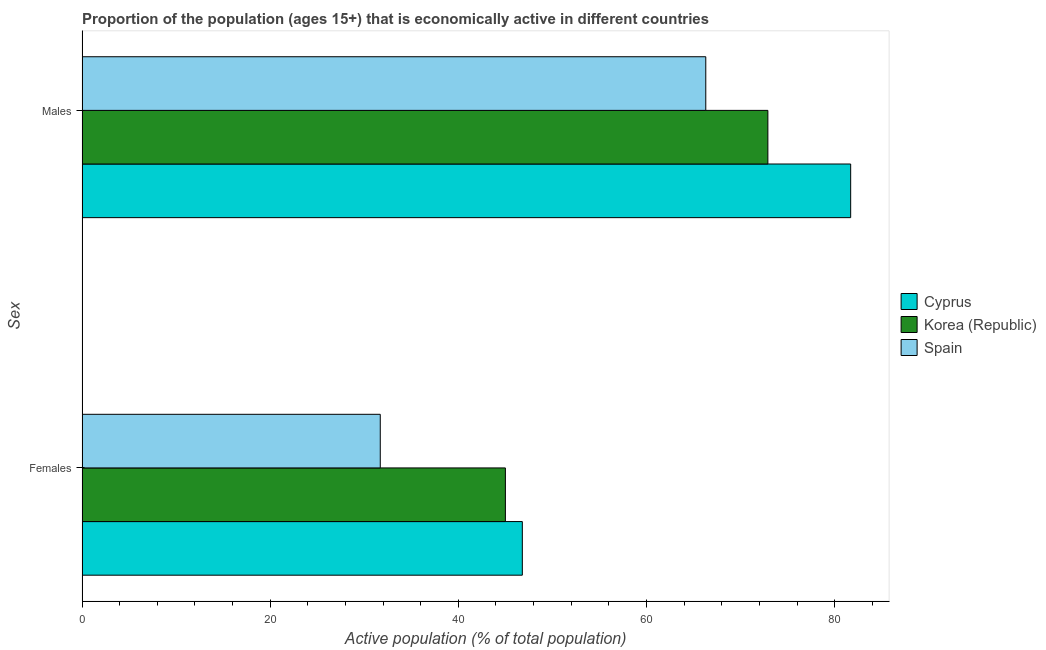How many different coloured bars are there?
Provide a short and direct response. 3. How many groups of bars are there?
Give a very brief answer. 2. Are the number of bars per tick equal to the number of legend labels?
Your response must be concise. Yes. How many bars are there on the 2nd tick from the top?
Provide a short and direct response. 3. What is the label of the 2nd group of bars from the top?
Provide a short and direct response. Females. What is the percentage of economically active female population in Spain?
Offer a terse response. 31.7. Across all countries, what is the maximum percentage of economically active male population?
Make the answer very short. 81.7. Across all countries, what is the minimum percentage of economically active female population?
Make the answer very short. 31.7. In which country was the percentage of economically active male population maximum?
Your answer should be compact. Cyprus. In which country was the percentage of economically active male population minimum?
Offer a terse response. Spain. What is the total percentage of economically active female population in the graph?
Ensure brevity in your answer.  123.5. What is the difference between the percentage of economically active female population in Korea (Republic) and that in Spain?
Your answer should be compact. 13.3. What is the difference between the percentage of economically active female population in Cyprus and the percentage of economically active male population in Korea (Republic)?
Ensure brevity in your answer.  -26.1. What is the average percentage of economically active female population per country?
Your response must be concise. 41.17. What is the difference between the percentage of economically active female population and percentage of economically active male population in Cyprus?
Provide a short and direct response. -34.9. What is the ratio of the percentage of economically active female population in Cyprus to that in Spain?
Ensure brevity in your answer.  1.48. In how many countries, is the percentage of economically active male population greater than the average percentage of economically active male population taken over all countries?
Provide a short and direct response. 1. What does the 1st bar from the bottom in Females represents?
Give a very brief answer. Cyprus. What is the difference between two consecutive major ticks on the X-axis?
Give a very brief answer. 20. Are the values on the major ticks of X-axis written in scientific E-notation?
Provide a succinct answer. No. Does the graph contain grids?
Your answer should be very brief. No. How are the legend labels stacked?
Give a very brief answer. Vertical. What is the title of the graph?
Make the answer very short. Proportion of the population (ages 15+) that is economically active in different countries. Does "Macedonia" appear as one of the legend labels in the graph?
Your response must be concise. No. What is the label or title of the X-axis?
Offer a terse response. Active population (% of total population). What is the label or title of the Y-axis?
Offer a very short reply. Sex. What is the Active population (% of total population) of Cyprus in Females?
Ensure brevity in your answer.  46.8. What is the Active population (% of total population) of Spain in Females?
Keep it short and to the point. 31.7. What is the Active population (% of total population) in Cyprus in Males?
Offer a terse response. 81.7. What is the Active population (% of total population) of Korea (Republic) in Males?
Your answer should be very brief. 72.9. What is the Active population (% of total population) of Spain in Males?
Your answer should be very brief. 66.3. Across all Sex, what is the maximum Active population (% of total population) in Cyprus?
Offer a terse response. 81.7. Across all Sex, what is the maximum Active population (% of total population) of Korea (Republic)?
Ensure brevity in your answer.  72.9. Across all Sex, what is the maximum Active population (% of total population) in Spain?
Your answer should be very brief. 66.3. Across all Sex, what is the minimum Active population (% of total population) in Cyprus?
Offer a very short reply. 46.8. Across all Sex, what is the minimum Active population (% of total population) of Korea (Republic)?
Provide a succinct answer. 45. Across all Sex, what is the minimum Active population (% of total population) in Spain?
Make the answer very short. 31.7. What is the total Active population (% of total population) in Cyprus in the graph?
Your response must be concise. 128.5. What is the total Active population (% of total population) of Korea (Republic) in the graph?
Your answer should be compact. 117.9. What is the difference between the Active population (% of total population) in Cyprus in Females and that in Males?
Provide a succinct answer. -34.9. What is the difference between the Active population (% of total population) of Korea (Republic) in Females and that in Males?
Your answer should be very brief. -27.9. What is the difference between the Active population (% of total population) in Spain in Females and that in Males?
Ensure brevity in your answer.  -34.6. What is the difference between the Active population (% of total population) in Cyprus in Females and the Active population (% of total population) in Korea (Republic) in Males?
Ensure brevity in your answer.  -26.1. What is the difference between the Active population (% of total population) of Cyprus in Females and the Active population (% of total population) of Spain in Males?
Your answer should be very brief. -19.5. What is the difference between the Active population (% of total population) of Korea (Republic) in Females and the Active population (% of total population) of Spain in Males?
Keep it short and to the point. -21.3. What is the average Active population (% of total population) of Cyprus per Sex?
Provide a short and direct response. 64.25. What is the average Active population (% of total population) of Korea (Republic) per Sex?
Your response must be concise. 58.95. What is the average Active population (% of total population) of Spain per Sex?
Provide a succinct answer. 49. What is the difference between the Active population (% of total population) of Cyprus and Active population (% of total population) of Korea (Republic) in Females?
Provide a succinct answer. 1.8. What is the difference between the Active population (% of total population) of Korea (Republic) and Active population (% of total population) of Spain in Males?
Give a very brief answer. 6.6. What is the ratio of the Active population (% of total population) in Cyprus in Females to that in Males?
Your answer should be very brief. 0.57. What is the ratio of the Active population (% of total population) of Korea (Republic) in Females to that in Males?
Ensure brevity in your answer.  0.62. What is the ratio of the Active population (% of total population) of Spain in Females to that in Males?
Provide a succinct answer. 0.48. What is the difference between the highest and the second highest Active population (% of total population) in Cyprus?
Your response must be concise. 34.9. What is the difference between the highest and the second highest Active population (% of total population) in Korea (Republic)?
Make the answer very short. 27.9. What is the difference between the highest and the second highest Active population (% of total population) of Spain?
Provide a short and direct response. 34.6. What is the difference between the highest and the lowest Active population (% of total population) in Cyprus?
Provide a short and direct response. 34.9. What is the difference between the highest and the lowest Active population (% of total population) in Korea (Republic)?
Your response must be concise. 27.9. What is the difference between the highest and the lowest Active population (% of total population) of Spain?
Make the answer very short. 34.6. 